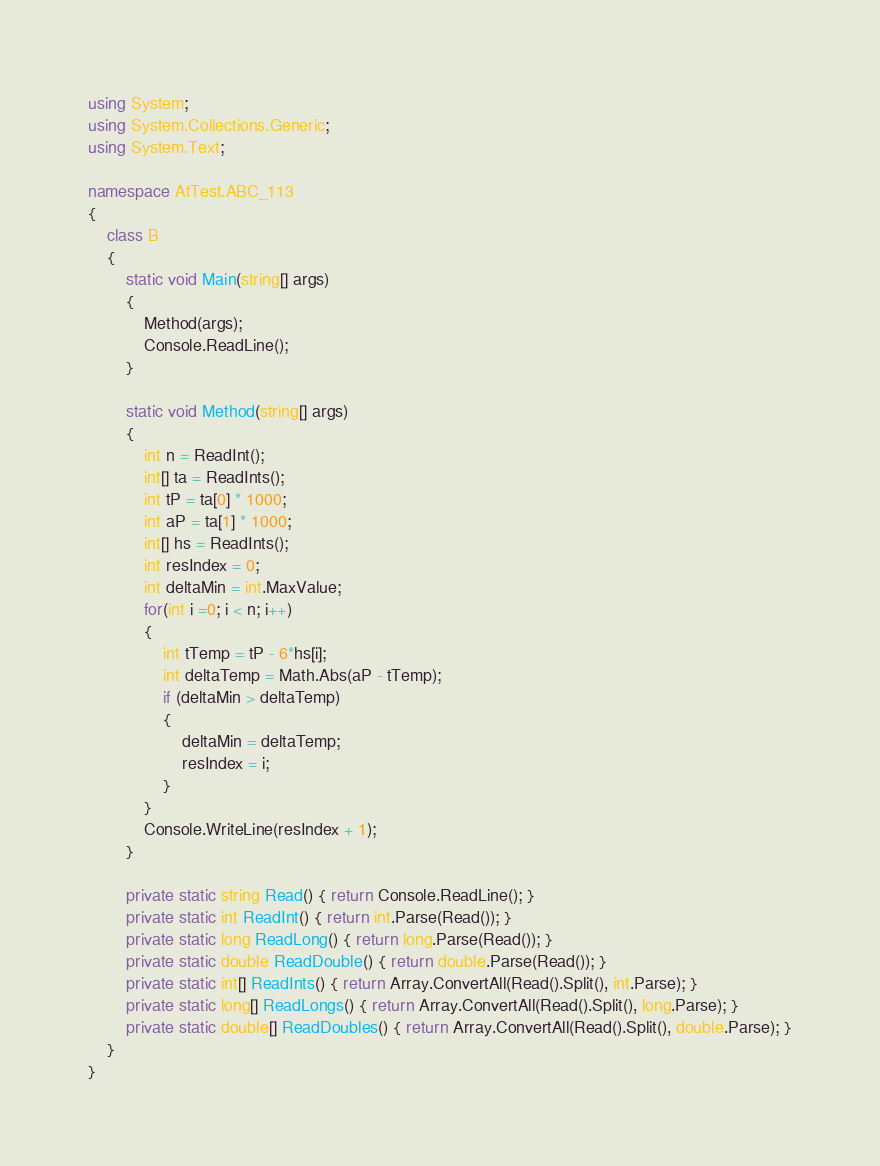Convert code to text. <code><loc_0><loc_0><loc_500><loc_500><_C#_>using System;
using System.Collections.Generic;
using System.Text;

namespace AtTest.ABC_113
{
    class B
    {
        static void Main(string[] args)
        {
            Method(args);
            Console.ReadLine();
        }

        static void Method(string[] args)
        {
            int n = ReadInt();
            int[] ta = ReadInts();
            int tP = ta[0] * 1000;
            int aP = ta[1] * 1000;
            int[] hs = ReadInts();
            int resIndex = 0;
            int deltaMin = int.MaxValue;
            for(int i =0; i < n; i++)
            {
                int tTemp = tP - 6*hs[i];
                int deltaTemp = Math.Abs(aP - tTemp);
                if (deltaMin > deltaTemp)
                {
                    deltaMin = deltaTemp;
                    resIndex = i;
                }
            }
            Console.WriteLine(resIndex + 1);
        }

        private static string Read() { return Console.ReadLine(); }
        private static int ReadInt() { return int.Parse(Read()); }
        private static long ReadLong() { return long.Parse(Read()); }
        private static double ReadDouble() { return double.Parse(Read()); }
        private static int[] ReadInts() { return Array.ConvertAll(Read().Split(), int.Parse); }
        private static long[] ReadLongs() { return Array.ConvertAll(Read().Split(), long.Parse); }
        private static double[] ReadDoubles() { return Array.ConvertAll(Read().Split(), double.Parse); }
    }
}
</code> 